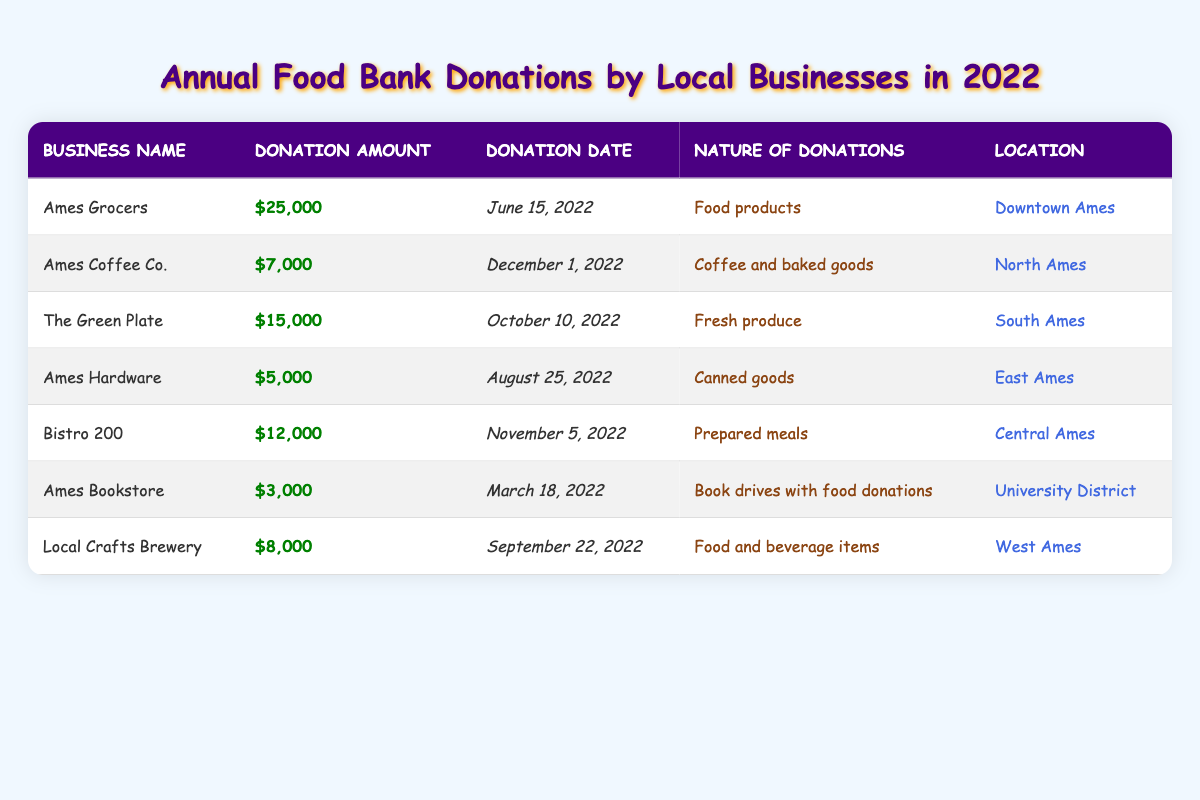What was the total donation amount by all businesses in 2022? We need to sum all the donation amounts listed in the table: $25,000 (Ames Grocers) + $7,000 (Ames Coffee Co.) + $15,000 (The Green Plate) + $5,000 (Ames Hardware) + $12,000 (Bistro 200) + $3,000 (Ames Bookstore) + $8,000 (Local Crafts Brewery) = $75,000.
Answer: $75,000 Which business made the largest donation? From the table, Ames Grocers donated $25,000, which is higher than any other donation listed.
Answer: Ames Grocers What type of donation did Ames Coffee Co. provide? The table indicates that Ames Coffee Co. donated coffee and baked goods.
Answer: Coffee and baked goods What was the donation amount of The Green Plate? The table clearly shows that The Green Plate donated $15,000.
Answer: $15,000 Did any business donate less than $5,000? Looking through the table, the minimum donation shown is $3,000 from Ames Bookstore, which is less than $5,000.
Answer: Yes What is the average donation amount across all businesses? We found the total donation of $75,000 from 7 businesses. Therefore, to find the average, we divide $75,000 by 7, which gives approximately $10,714.29.
Answer: $10,714.29 How many businesses are located in North Ames? Reviewing the table, there is only one business (Ames Coffee Co.) listed with a location in North Ames.
Answer: 1 What is the difference in donations between the largest and smallest donation? The largest donation is $25,000 (Ames Grocers) and the smallest is $3,000 (Ames Bookstore). The difference is $25,000 - $3,000 = $22,000.
Answer: $22,000 Which business donated prepared meals? The table states that Bistro 200 donated prepared meals.
Answer: Bistro 200 What percentage of the total donations was made by Ames Grocers? Ames Grocers donated $25,000, which is part of the total $75,000. To find the percentage, we divide $25,000 by $75,000 and multiply by 100, resulting in approximately 33.33%.
Answer: 33.33% 